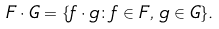<formula> <loc_0><loc_0><loc_500><loc_500>F \cdot G = \{ f \cdot g \colon f \in F , \, g \in G \} .</formula> 